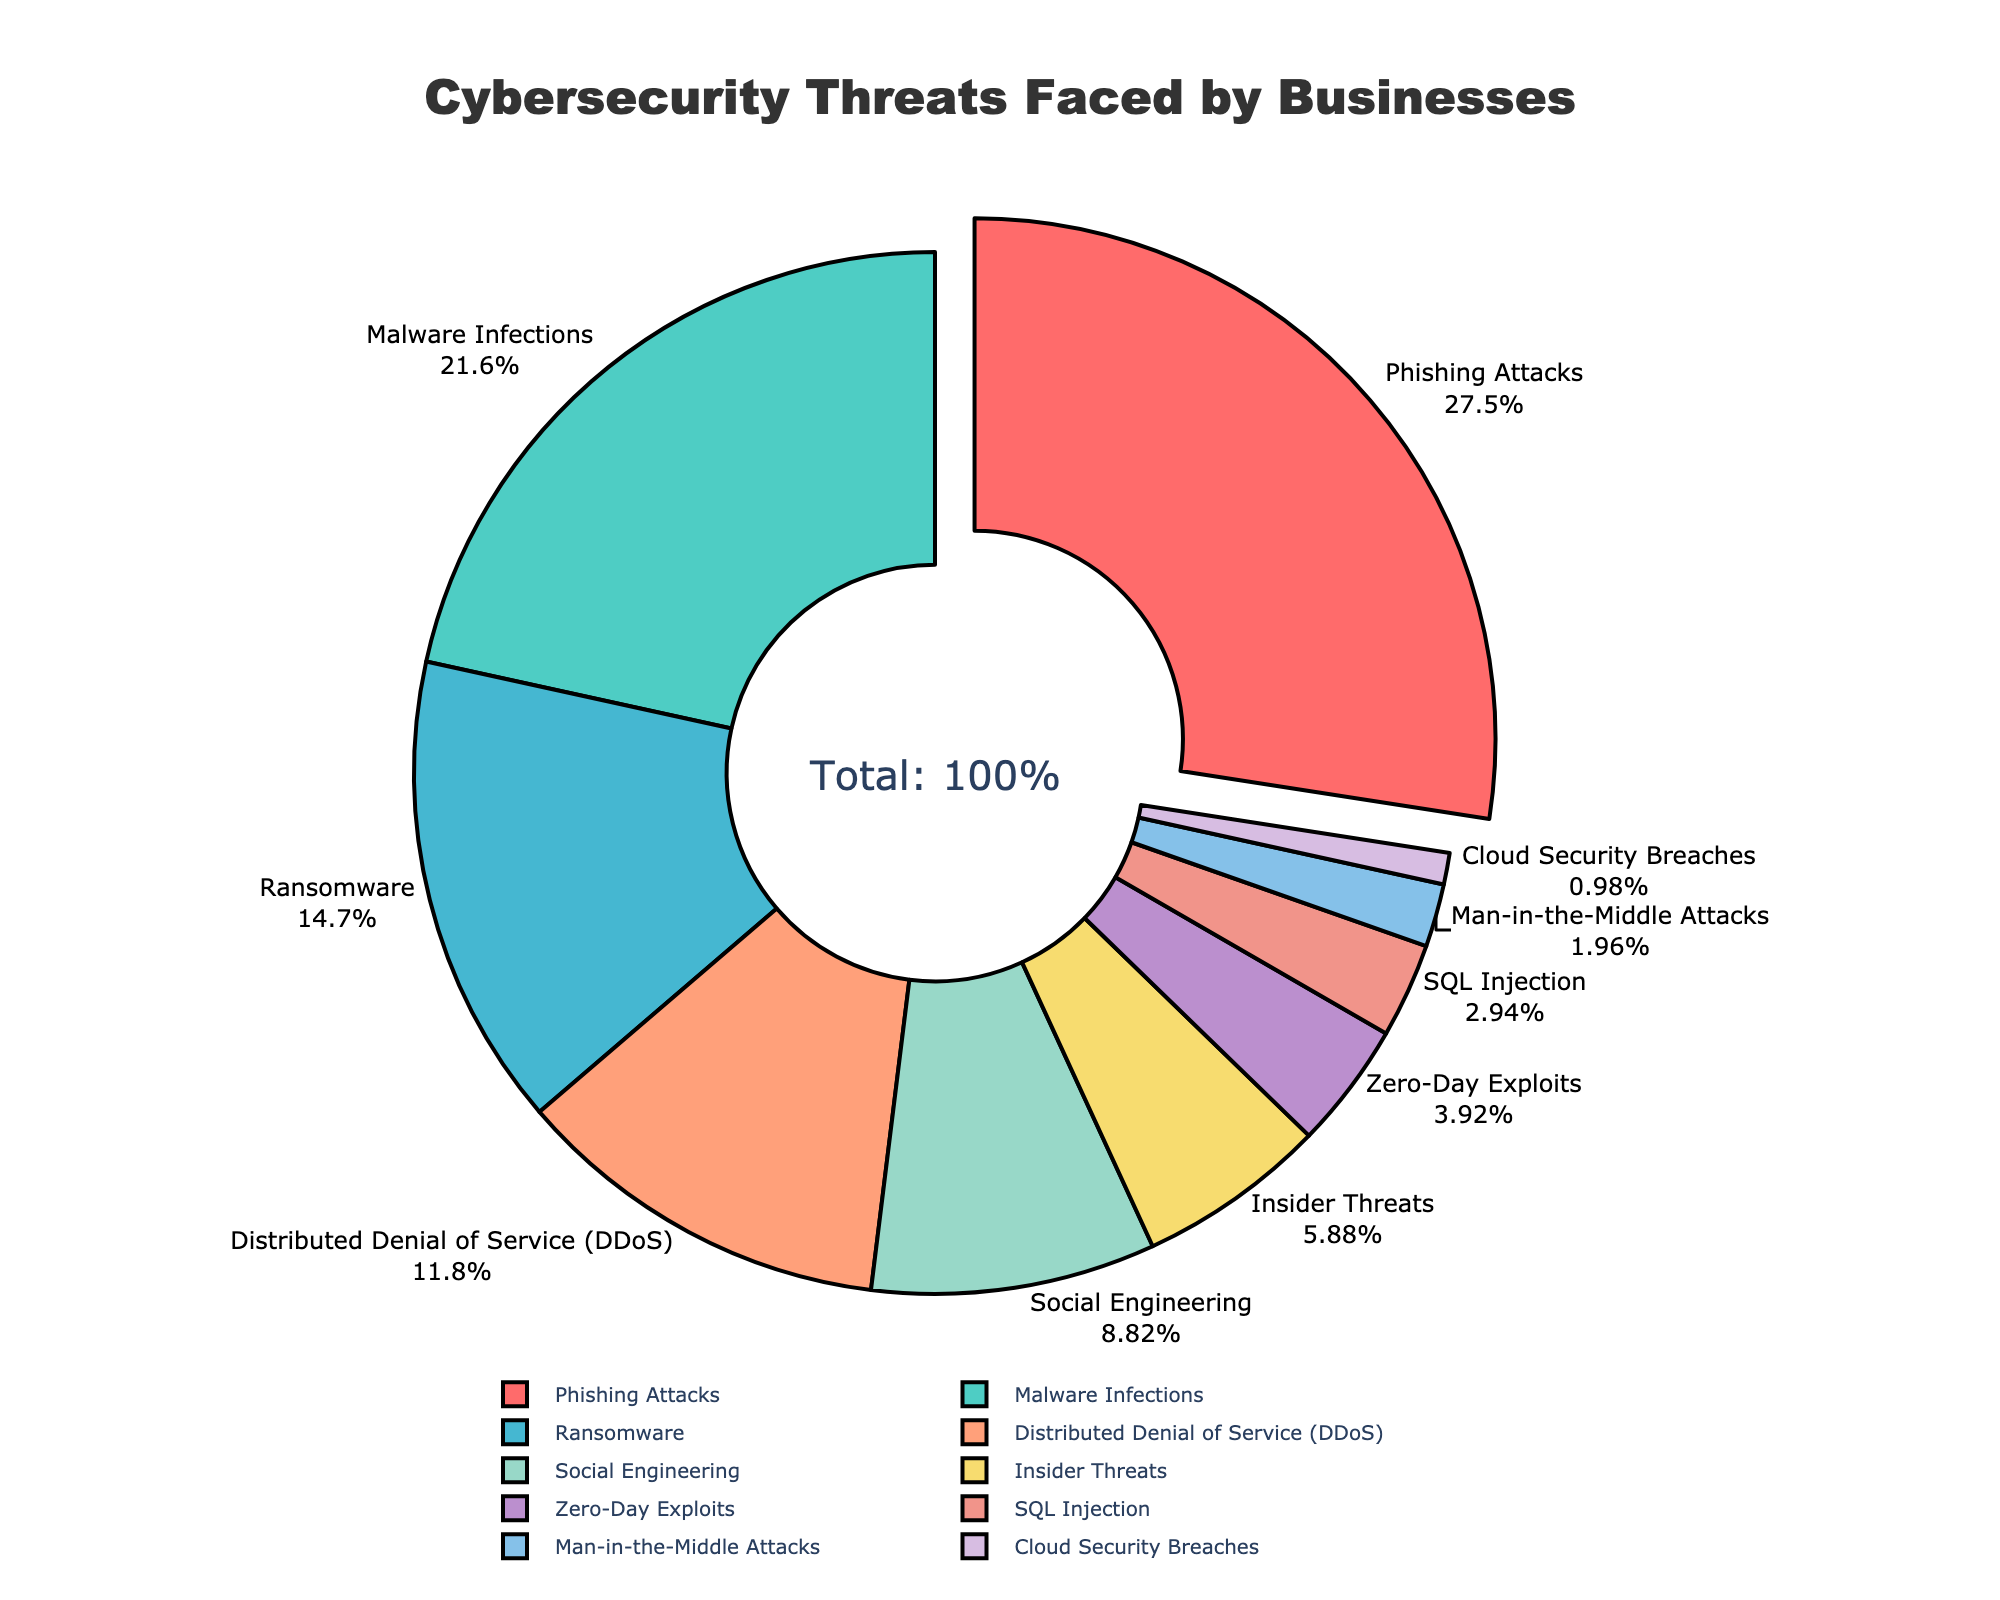What is the largest cybersecurity threat faced by businesses? The largest segment in the pie chart appears to be related to Phishing Attacks, which has the highest percentage. To determine this, locate the segment with the highest numerical value, which is 28%.
Answer: Phishing Attacks What percentage of businesses face Malware Infections and Ransomware threats combined? To find the combined percentage, add the Malware Infections percentage (22%) to the Ransomware percentage (15%). The sum is 22% + 15% = 37%.
Answer: 37% Which threat type is represented by the orange color in the chart? The orange segment corresponds to Ransomware. Identify this by matching the color segment on the chart to its label.
Answer: Ransomware How much higher is the percentage of businesses facing Phishing Attacks compared to those facing Social Engineering threats? To determine the difference, subtract the percentage of Social Engineering (9%) from the percentage of Phishing Attacks (28%). This yields 28% - 9% = 19%.
Answer: 19% Are Insider Threats more common than SQL Injection or less common? Compare the percentages of Insider Threats (6%) to SQL Injection (3%). Since 6% is greater than 3%, Insider Threats are more common than SQL Injection.
Answer: More common What is the total percentage of businesses facing either Social Engineering or Insider Threats? Add the percentages of Social Engineering (9%) and Insider Threats (6%). The total is 9% + 6% = 15%.
Answer: 15% How many threat types have a percentage of less than 5%? Count the segments on the chart with percentages lower than 5%: Zero-Day Exploits (4%), SQL Injection (3%), Man-in-the-Middle Attacks (2%), and Cloud Security Breaches (1%). This results in 4 threat types.
Answer: 4 Is the percentage of Distributed Denial of Service (DDoS) threats higher than the percentage of Insider Threats? Compare the percentages: Distributed Denial of Service (12%) versus Insider Threats (6%). Since 12% is greater than 6%, DDoS threats are higher.
Answer: Higher What is the average percentage of Phishing Attacks, Malware Infections, and Ransomware threats? Calculate the average by summing the percentages of the three threats: 28% + 22% + 15% = 65%. Then divide by 3, which gives an average of 65% / 3 ≈ 21.67%.
Answer: 21.67% What visual feature makes the largest threat type stand out in the chart? The largest threat, Phishing Attacks, is visually emphasized by being slightly pulled out from the rest of the pie chart. This distinction highlights its significance.
Answer: Pulled out segment 